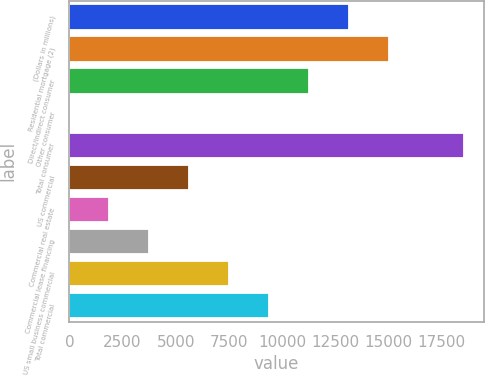<chart> <loc_0><loc_0><loc_500><loc_500><bar_chart><fcel>(Dollars in millions)<fcel>Residential mortgage (2)<fcel>Direct/Indirect consumer<fcel>Other consumer<fcel>Total consumer<fcel>US commercial<fcel>Commercial real estate<fcel>Commercial lease financing<fcel>US small business commercial<fcel>Total commercial<nl><fcel>13131.9<fcel>15007.6<fcel>11256.2<fcel>2<fcel>18555<fcel>5629.1<fcel>1877.7<fcel>3753.4<fcel>7504.8<fcel>9380.5<nl></chart> 